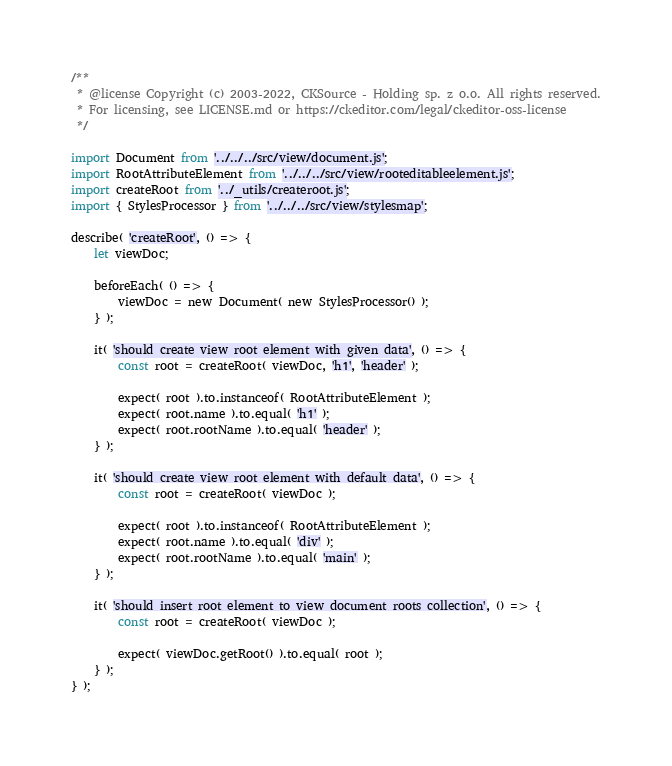Convert code to text. <code><loc_0><loc_0><loc_500><loc_500><_JavaScript_>/**
 * @license Copyright (c) 2003-2022, CKSource - Holding sp. z o.o. All rights reserved.
 * For licensing, see LICENSE.md or https://ckeditor.com/legal/ckeditor-oss-license
 */

import Document from '../../../src/view/document.js';
import RootAttributeElement from '../../../src/view/rooteditableelement.js';
import createRoot from '../_utils/createroot.js';
import { StylesProcessor } from '../../../src/view/stylesmap';

describe( 'createRoot', () => {
	let viewDoc;

	beforeEach( () => {
		viewDoc = new Document( new StylesProcessor() );
	} );

	it( 'should create view root element with given data', () => {
		const root = createRoot( viewDoc, 'h1', 'header' );

		expect( root ).to.instanceof( RootAttributeElement );
		expect( root.name ).to.equal( 'h1' );
		expect( root.rootName ).to.equal( 'header' );
	} );

	it( 'should create view root element with default data', () => {
		const root = createRoot( viewDoc );

		expect( root ).to.instanceof( RootAttributeElement );
		expect( root.name ).to.equal( 'div' );
		expect( root.rootName ).to.equal( 'main' );
	} );

	it( 'should insert root element to view document roots collection', () => {
		const root = createRoot( viewDoc );

		expect( viewDoc.getRoot() ).to.equal( root );
	} );
} );
</code> 